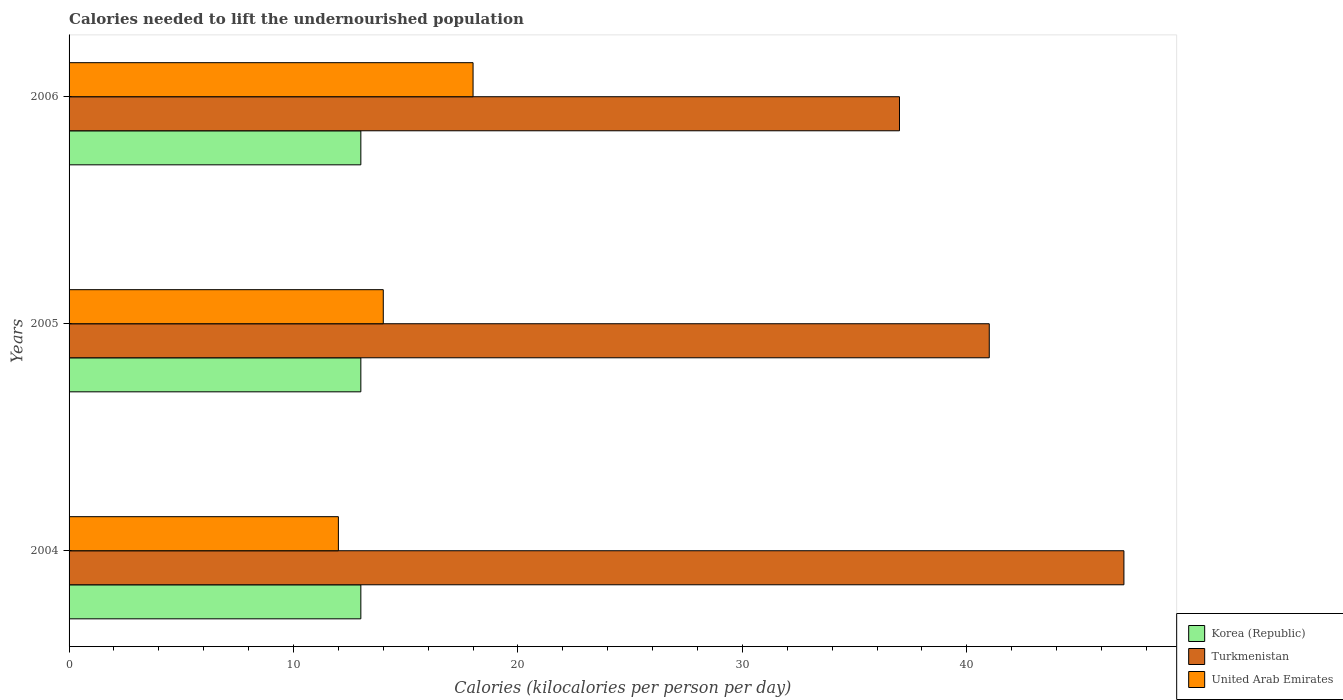How many different coloured bars are there?
Provide a succinct answer. 3. How many groups of bars are there?
Keep it short and to the point. 3. Are the number of bars per tick equal to the number of legend labels?
Give a very brief answer. Yes. How many bars are there on the 2nd tick from the bottom?
Your answer should be compact. 3. What is the label of the 3rd group of bars from the top?
Ensure brevity in your answer.  2004. In how many cases, is the number of bars for a given year not equal to the number of legend labels?
Your answer should be compact. 0. What is the total calories needed to lift the undernourished population in Korea (Republic) in 2006?
Keep it short and to the point. 13. Across all years, what is the maximum total calories needed to lift the undernourished population in United Arab Emirates?
Your response must be concise. 18. Across all years, what is the minimum total calories needed to lift the undernourished population in Turkmenistan?
Give a very brief answer. 37. What is the total total calories needed to lift the undernourished population in Turkmenistan in the graph?
Keep it short and to the point. 125. What is the difference between the total calories needed to lift the undernourished population in United Arab Emirates in 2005 and that in 2006?
Give a very brief answer. -4. What is the difference between the total calories needed to lift the undernourished population in Korea (Republic) in 2006 and the total calories needed to lift the undernourished population in United Arab Emirates in 2005?
Your response must be concise. -1. What is the average total calories needed to lift the undernourished population in United Arab Emirates per year?
Your answer should be compact. 14.67. In the year 2006, what is the difference between the total calories needed to lift the undernourished population in Turkmenistan and total calories needed to lift the undernourished population in United Arab Emirates?
Offer a terse response. 19. In how many years, is the total calories needed to lift the undernourished population in Korea (Republic) greater than 18 kilocalories?
Make the answer very short. 0. What is the ratio of the total calories needed to lift the undernourished population in Turkmenistan in 2004 to that in 2005?
Your response must be concise. 1.15. Is the total calories needed to lift the undernourished population in United Arab Emirates in 2004 less than that in 2006?
Ensure brevity in your answer.  Yes. What does the 1st bar from the top in 2006 represents?
Give a very brief answer. United Arab Emirates. Are all the bars in the graph horizontal?
Offer a terse response. Yes. How many years are there in the graph?
Your answer should be very brief. 3. Are the values on the major ticks of X-axis written in scientific E-notation?
Your answer should be compact. No. Does the graph contain grids?
Provide a succinct answer. No. What is the title of the graph?
Keep it short and to the point. Calories needed to lift the undernourished population. Does "Guatemala" appear as one of the legend labels in the graph?
Make the answer very short. No. What is the label or title of the X-axis?
Keep it short and to the point. Calories (kilocalories per person per day). What is the Calories (kilocalories per person per day) of United Arab Emirates in 2004?
Provide a succinct answer. 12. What is the Calories (kilocalories per person per day) in Korea (Republic) in 2005?
Give a very brief answer. 13. What is the Calories (kilocalories per person per day) in United Arab Emirates in 2005?
Your response must be concise. 14. What is the Calories (kilocalories per person per day) of Korea (Republic) in 2006?
Make the answer very short. 13. What is the Calories (kilocalories per person per day) of Turkmenistan in 2006?
Your answer should be very brief. 37. Across all years, what is the maximum Calories (kilocalories per person per day) of Turkmenistan?
Provide a succinct answer. 47. What is the total Calories (kilocalories per person per day) in Turkmenistan in the graph?
Ensure brevity in your answer.  125. What is the total Calories (kilocalories per person per day) of United Arab Emirates in the graph?
Your answer should be very brief. 44. What is the difference between the Calories (kilocalories per person per day) in Turkmenistan in 2004 and that in 2005?
Provide a succinct answer. 6. What is the difference between the Calories (kilocalories per person per day) in United Arab Emirates in 2004 and that in 2005?
Offer a very short reply. -2. What is the difference between the Calories (kilocalories per person per day) in Korea (Republic) in 2004 and that in 2006?
Offer a very short reply. 0. What is the difference between the Calories (kilocalories per person per day) in Turkmenistan in 2005 and that in 2006?
Keep it short and to the point. 4. What is the difference between the Calories (kilocalories per person per day) of Korea (Republic) in 2004 and the Calories (kilocalories per person per day) of Turkmenistan in 2005?
Make the answer very short. -28. What is the difference between the Calories (kilocalories per person per day) of Korea (Republic) in 2005 and the Calories (kilocalories per person per day) of United Arab Emirates in 2006?
Give a very brief answer. -5. What is the difference between the Calories (kilocalories per person per day) of Turkmenistan in 2005 and the Calories (kilocalories per person per day) of United Arab Emirates in 2006?
Keep it short and to the point. 23. What is the average Calories (kilocalories per person per day) of Turkmenistan per year?
Your answer should be very brief. 41.67. What is the average Calories (kilocalories per person per day) in United Arab Emirates per year?
Ensure brevity in your answer.  14.67. In the year 2004, what is the difference between the Calories (kilocalories per person per day) in Korea (Republic) and Calories (kilocalories per person per day) in Turkmenistan?
Provide a succinct answer. -34. In the year 2004, what is the difference between the Calories (kilocalories per person per day) of Korea (Republic) and Calories (kilocalories per person per day) of United Arab Emirates?
Your answer should be compact. 1. In the year 2004, what is the difference between the Calories (kilocalories per person per day) in Turkmenistan and Calories (kilocalories per person per day) in United Arab Emirates?
Offer a very short reply. 35. In the year 2005, what is the difference between the Calories (kilocalories per person per day) in Korea (Republic) and Calories (kilocalories per person per day) in United Arab Emirates?
Your answer should be compact. -1. In the year 2006, what is the difference between the Calories (kilocalories per person per day) of Turkmenistan and Calories (kilocalories per person per day) of United Arab Emirates?
Give a very brief answer. 19. What is the ratio of the Calories (kilocalories per person per day) of Korea (Republic) in 2004 to that in 2005?
Your answer should be compact. 1. What is the ratio of the Calories (kilocalories per person per day) of Turkmenistan in 2004 to that in 2005?
Your answer should be very brief. 1.15. What is the ratio of the Calories (kilocalories per person per day) of United Arab Emirates in 2004 to that in 2005?
Make the answer very short. 0.86. What is the ratio of the Calories (kilocalories per person per day) of Korea (Republic) in 2004 to that in 2006?
Ensure brevity in your answer.  1. What is the ratio of the Calories (kilocalories per person per day) in Turkmenistan in 2004 to that in 2006?
Offer a terse response. 1.27. What is the ratio of the Calories (kilocalories per person per day) of United Arab Emirates in 2004 to that in 2006?
Provide a short and direct response. 0.67. What is the ratio of the Calories (kilocalories per person per day) in Turkmenistan in 2005 to that in 2006?
Your answer should be very brief. 1.11. What is the difference between the highest and the second highest Calories (kilocalories per person per day) of Korea (Republic)?
Your answer should be compact. 0. What is the difference between the highest and the lowest Calories (kilocalories per person per day) of Turkmenistan?
Your answer should be compact. 10. What is the difference between the highest and the lowest Calories (kilocalories per person per day) in United Arab Emirates?
Ensure brevity in your answer.  6. 